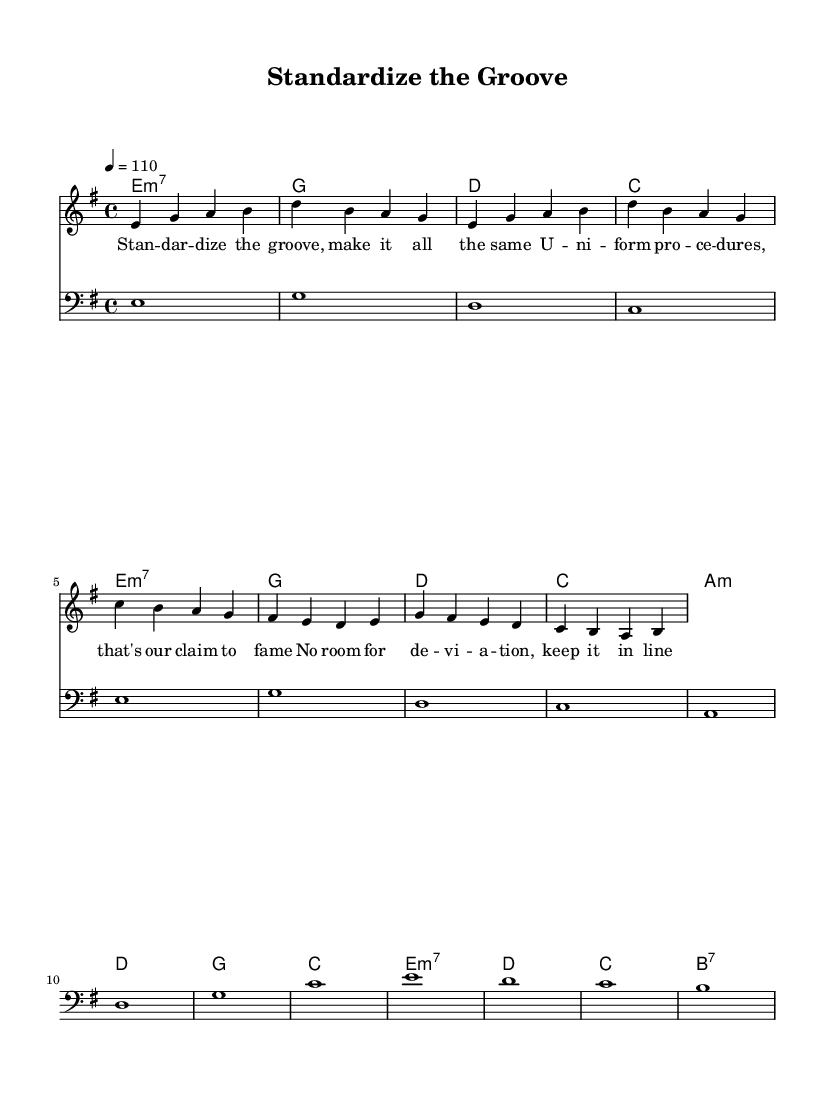What is the key signature of this music? The key signature is E minor, indicated by one sharp (F#) and the minor nature of the melody.
Answer: E minor What is the time signature of this music? The time signature is 4/4, which means there are four beats in each measure. This is indicated at the beginning of the score.
Answer: 4/4 What is the tempo marking for this piece? The tempo marking is 110 beats per minute, indicated by the tempo instruction at the beginning.
Answer: 110 How many measures are in the melody? The melody consists of 8 measures, which can be counted by the number of vertical bars separating the groups of notes.
Answer: 8 What is the function of the bass clef in this piece? The bass clef provides the lower range notes that support the harmony and rhythm of the music, complementing the melody.
Answer: Support harmony Which section of the lyrics emphasizes the need for uniformity? The phrase "Uniform procedures" directly calls out the need for standardization in public services.
Answer: Uniform procedures What type of chords are predominantly used in the harmonies section? The chords include minor seventh chords and major chords, which are common in funk music for creating a groovy feel.
Answer: Minor seventh chords 